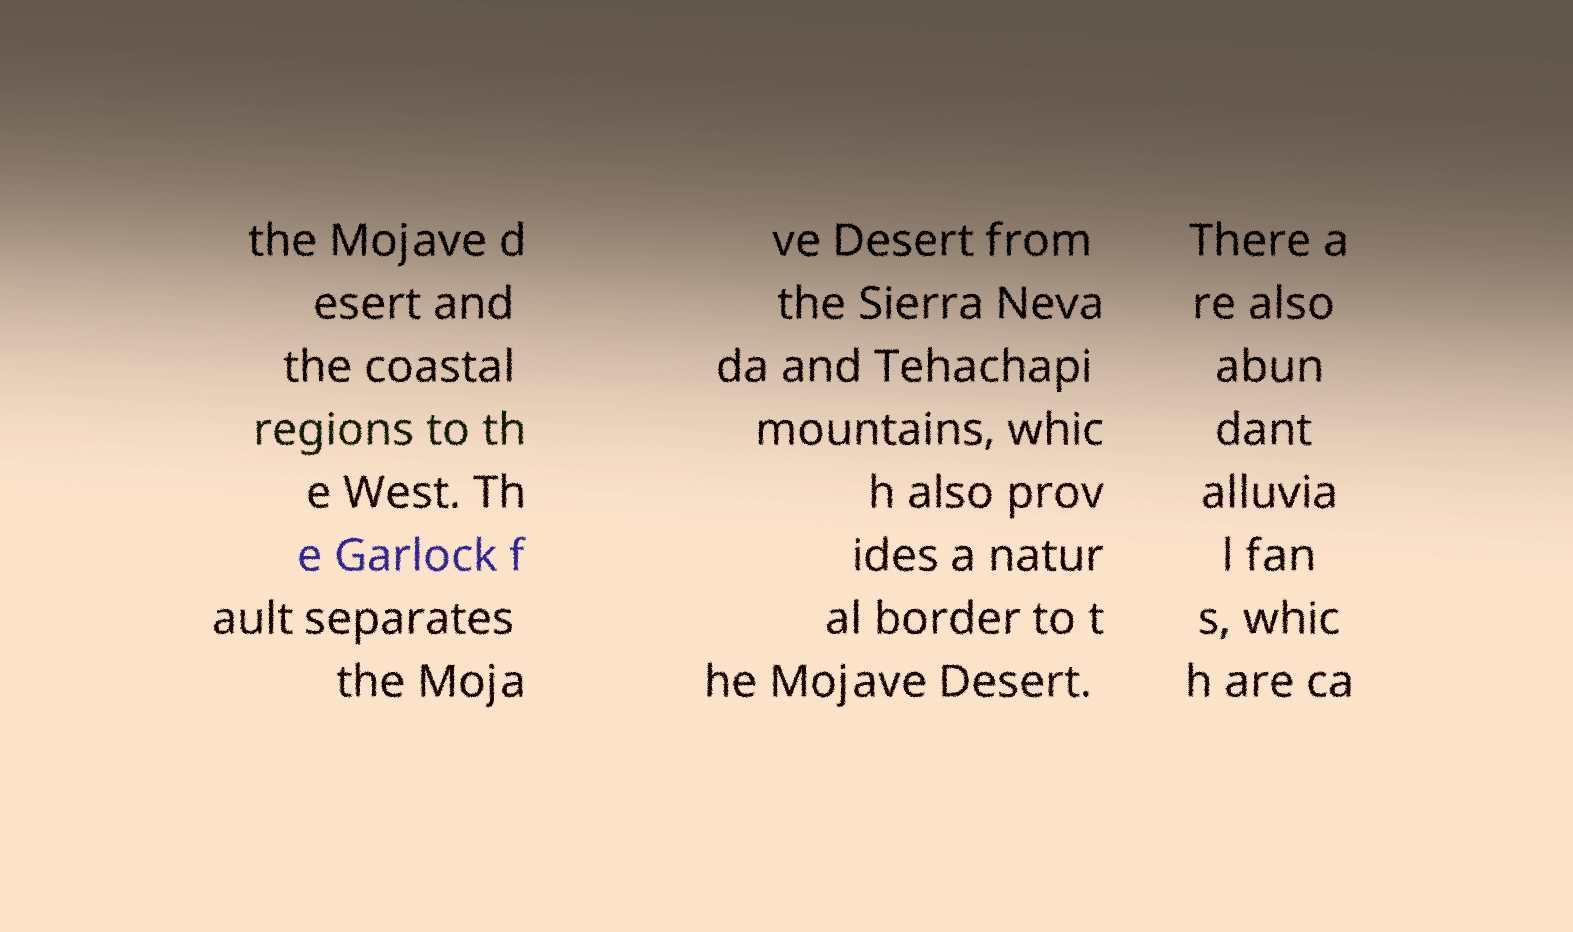Could you extract and type out the text from this image? the Mojave d esert and the coastal regions to th e West. Th e Garlock f ault separates the Moja ve Desert from the Sierra Neva da and Tehachapi mountains, whic h also prov ides a natur al border to t he Mojave Desert. There a re also abun dant alluvia l fan s, whic h are ca 